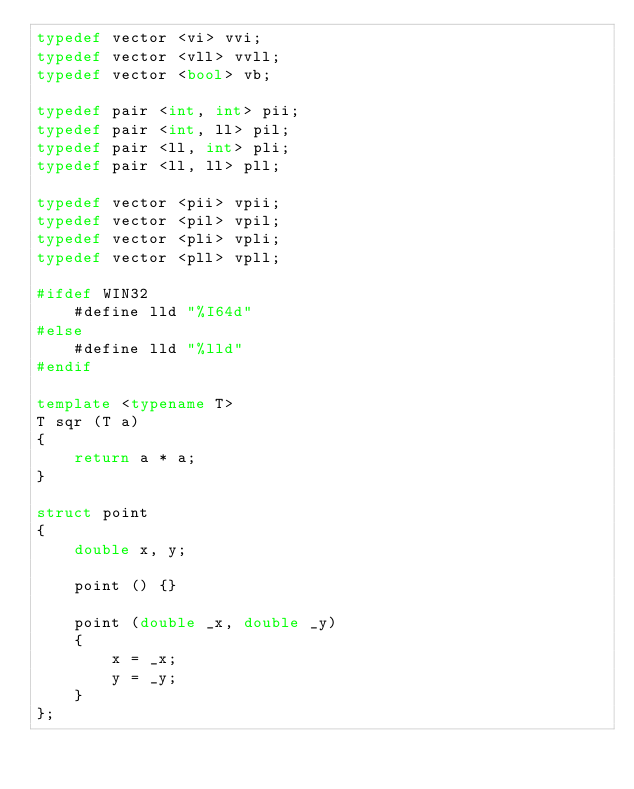Convert code to text. <code><loc_0><loc_0><loc_500><loc_500><_C++_>typedef vector <vi> vvi;
typedef vector <vll> vvll;
typedef vector <bool> vb;

typedef pair <int, int> pii;
typedef pair <int, ll> pil;
typedef pair <ll, int> pli;
typedef pair <ll, ll> pll;

typedef vector <pii> vpii;
typedef vector <pil> vpil;
typedef vector <pli> vpli;
typedef vector <pll> vpll;

#ifdef WIN32
    #define lld "%I64d"
#else
    #define lld "%lld"
#endif

template <typename T>
T sqr (T a)
{
    return a * a;
}

struct point
{
    double x, y;

    point () {}

    point (double _x, double _y)
    {
        x = _x;
        y = _y;
    }
};
</code> 